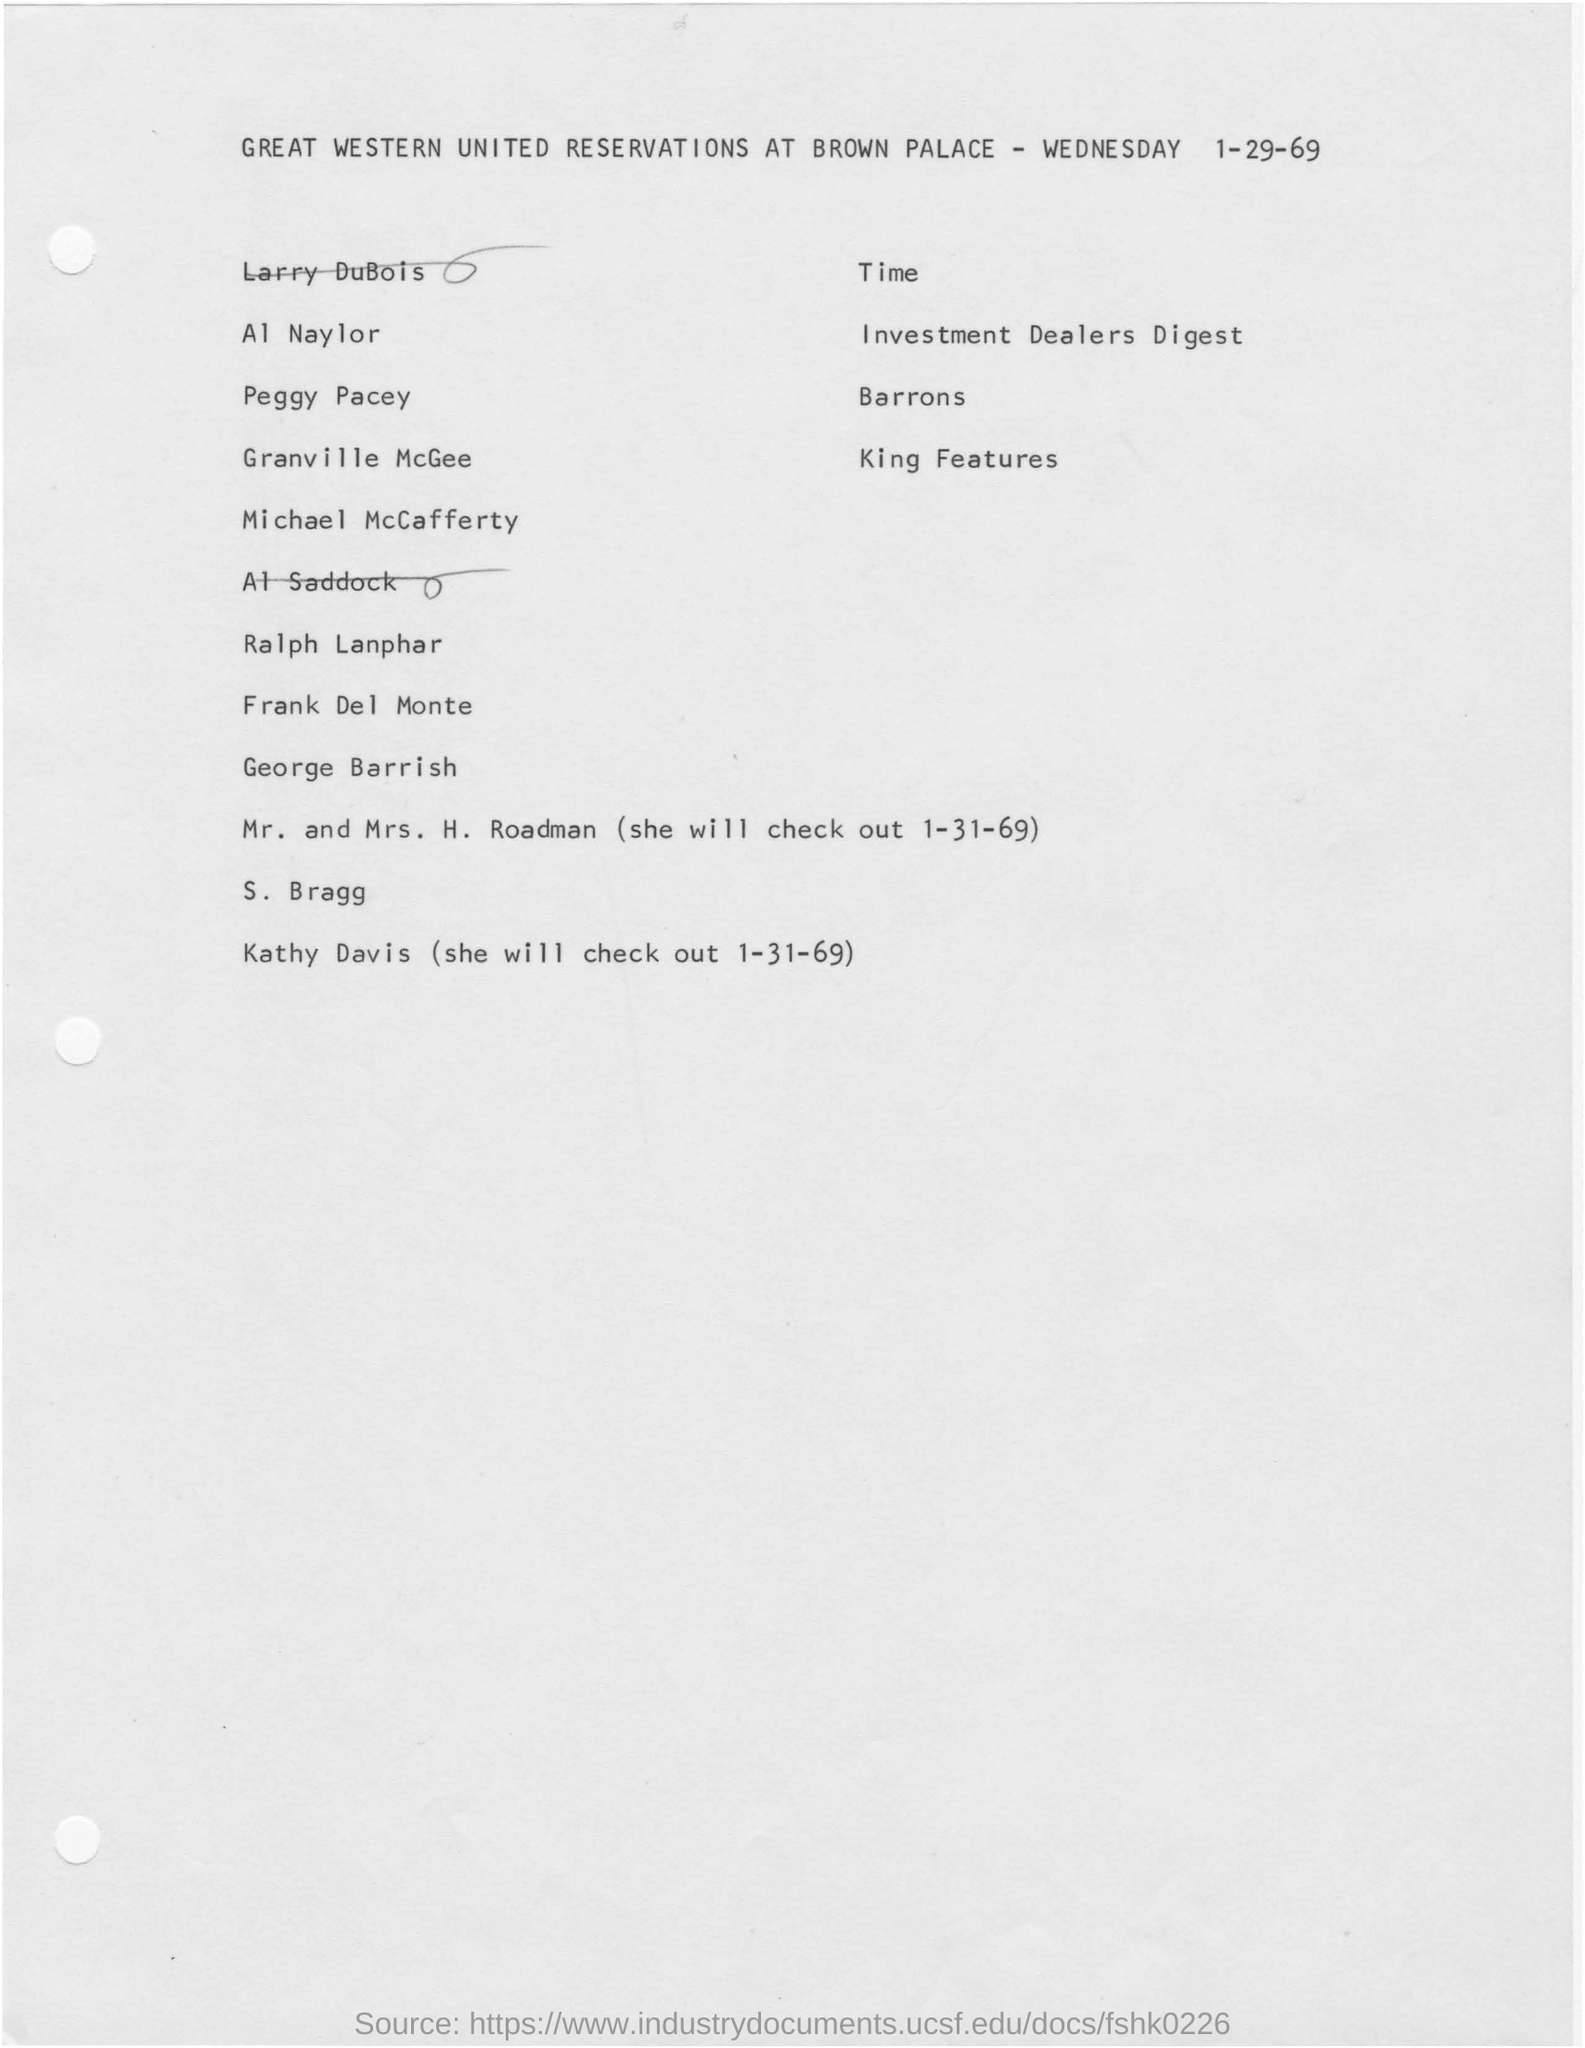Draw attention to some important aspects in this diagram. The day mentioned in the given page is Wednesday. 